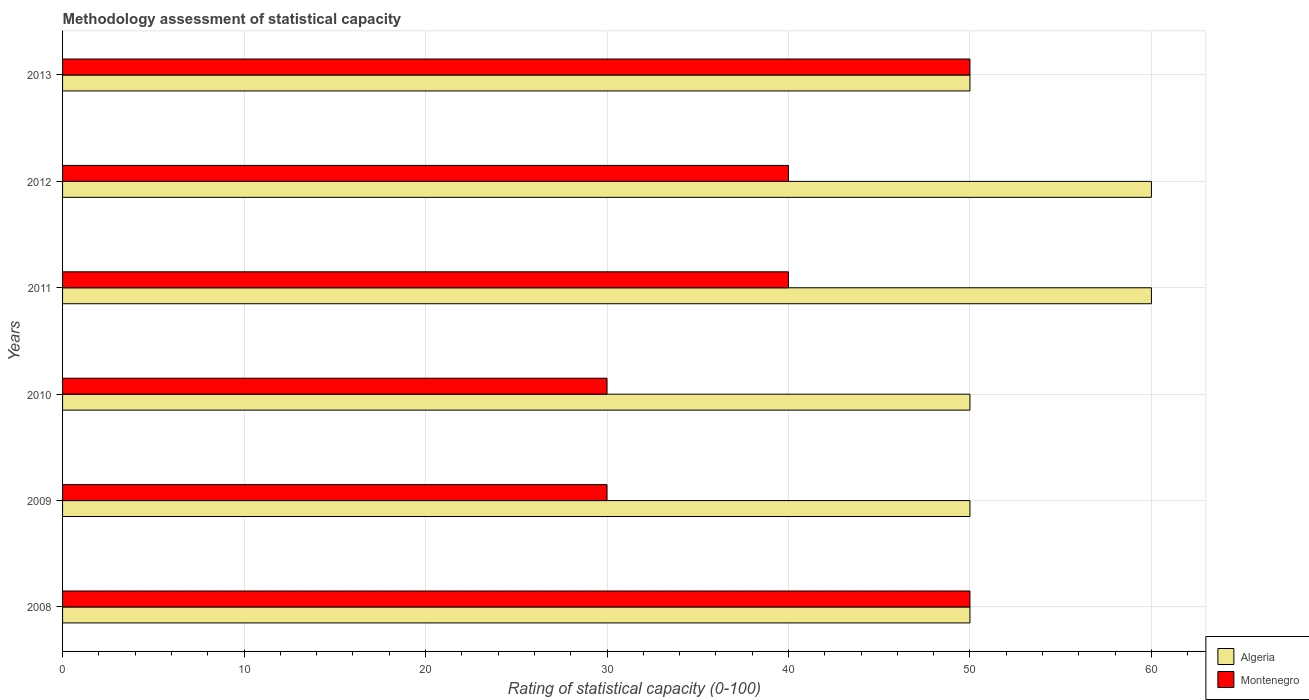How many groups of bars are there?
Offer a terse response. 6. Are the number of bars per tick equal to the number of legend labels?
Your response must be concise. Yes. How many bars are there on the 4th tick from the top?
Your answer should be compact. 2. In how many cases, is the number of bars for a given year not equal to the number of legend labels?
Your answer should be compact. 0. What is the rating of statistical capacity in Montenegro in 2008?
Ensure brevity in your answer.  50. Across all years, what is the maximum rating of statistical capacity in Montenegro?
Provide a short and direct response. 50. Across all years, what is the minimum rating of statistical capacity in Algeria?
Your answer should be very brief. 50. What is the total rating of statistical capacity in Algeria in the graph?
Offer a terse response. 320. What is the difference between the rating of statistical capacity in Montenegro in 2008 and that in 2012?
Ensure brevity in your answer.  10. What is the difference between the rating of statistical capacity in Montenegro in 2010 and the rating of statistical capacity in Algeria in 2012?
Keep it short and to the point. -30. What is the average rating of statistical capacity in Algeria per year?
Your response must be concise. 53.33. In the year 2012, what is the difference between the rating of statistical capacity in Algeria and rating of statistical capacity in Montenegro?
Give a very brief answer. 20. What is the ratio of the rating of statistical capacity in Algeria in 2008 to that in 2011?
Give a very brief answer. 0.83. Is the difference between the rating of statistical capacity in Algeria in 2011 and 2013 greater than the difference between the rating of statistical capacity in Montenegro in 2011 and 2013?
Your response must be concise. Yes. What is the difference between the highest and the lowest rating of statistical capacity in Algeria?
Make the answer very short. 10. What does the 2nd bar from the top in 2013 represents?
Make the answer very short. Algeria. What does the 1st bar from the bottom in 2009 represents?
Provide a succinct answer. Algeria. Are all the bars in the graph horizontal?
Ensure brevity in your answer.  Yes. Does the graph contain grids?
Make the answer very short. Yes. How many legend labels are there?
Keep it short and to the point. 2. What is the title of the graph?
Provide a short and direct response. Methodology assessment of statistical capacity. Does "Brunei Darussalam" appear as one of the legend labels in the graph?
Provide a succinct answer. No. What is the label or title of the X-axis?
Make the answer very short. Rating of statistical capacity (0-100). What is the label or title of the Y-axis?
Ensure brevity in your answer.  Years. What is the Rating of statistical capacity (0-100) of Algeria in 2009?
Your answer should be compact. 50. What is the Rating of statistical capacity (0-100) of Algeria in 2010?
Keep it short and to the point. 50. What is the Rating of statistical capacity (0-100) in Montenegro in 2010?
Offer a terse response. 30. What is the Rating of statistical capacity (0-100) in Algeria in 2012?
Offer a terse response. 60. What is the Rating of statistical capacity (0-100) of Montenegro in 2012?
Your response must be concise. 40. What is the Rating of statistical capacity (0-100) of Algeria in 2013?
Your response must be concise. 50. What is the Rating of statistical capacity (0-100) of Montenegro in 2013?
Make the answer very short. 50. Across all years, what is the maximum Rating of statistical capacity (0-100) in Algeria?
Give a very brief answer. 60. Across all years, what is the minimum Rating of statistical capacity (0-100) in Algeria?
Make the answer very short. 50. What is the total Rating of statistical capacity (0-100) in Algeria in the graph?
Provide a short and direct response. 320. What is the total Rating of statistical capacity (0-100) of Montenegro in the graph?
Provide a succinct answer. 240. What is the difference between the Rating of statistical capacity (0-100) in Montenegro in 2008 and that in 2010?
Your answer should be very brief. 20. What is the difference between the Rating of statistical capacity (0-100) of Algeria in 2008 and that in 2011?
Make the answer very short. -10. What is the difference between the Rating of statistical capacity (0-100) of Montenegro in 2008 and that in 2011?
Offer a very short reply. 10. What is the difference between the Rating of statistical capacity (0-100) in Algeria in 2008 and that in 2013?
Provide a short and direct response. 0. What is the difference between the Rating of statistical capacity (0-100) of Montenegro in 2009 and that in 2010?
Your answer should be very brief. 0. What is the difference between the Rating of statistical capacity (0-100) of Montenegro in 2009 and that in 2011?
Provide a short and direct response. -10. What is the difference between the Rating of statistical capacity (0-100) of Montenegro in 2009 and that in 2012?
Your answer should be compact. -10. What is the difference between the Rating of statistical capacity (0-100) of Montenegro in 2010 and that in 2011?
Provide a succinct answer. -10. What is the difference between the Rating of statistical capacity (0-100) of Montenegro in 2010 and that in 2013?
Offer a terse response. -20. What is the difference between the Rating of statistical capacity (0-100) of Algeria in 2011 and that in 2013?
Make the answer very short. 10. What is the difference between the Rating of statistical capacity (0-100) of Montenegro in 2012 and that in 2013?
Your response must be concise. -10. What is the difference between the Rating of statistical capacity (0-100) in Algeria in 2008 and the Rating of statistical capacity (0-100) in Montenegro in 2010?
Ensure brevity in your answer.  20. What is the difference between the Rating of statistical capacity (0-100) of Algeria in 2008 and the Rating of statistical capacity (0-100) of Montenegro in 2011?
Offer a terse response. 10. What is the difference between the Rating of statistical capacity (0-100) of Algeria in 2009 and the Rating of statistical capacity (0-100) of Montenegro in 2010?
Ensure brevity in your answer.  20. What is the difference between the Rating of statistical capacity (0-100) in Algeria in 2009 and the Rating of statistical capacity (0-100) in Montenegro in 2012?
Offer a terse response. 10. What is the difference between the Rating of statistical capacity (0-100) of Algeria in 2010 and the Rating of statistical capacity (0-100) of Montenegro in 2011?
Give a very brief answer. 10. What is the difference between the Rating of statistical capacity (0-100) of Algeria in 2010 and the Rating of statistical capacity (0-100) of Montenegro in 2012?
Make the answer very short. 10. What is the difference between the Rating of statistical capacity (0-100) in Algeria in 2011 and the Rating of statistical capacity (0-100) in Montenegro in 2012?
Offer a very short reply. 20. What is the difference between the Rating of statistical capacity (0-100) of Algeria in 2012 and the Rating of statistical capacity (0-100) of Montenegro in 2013?
Your answer should be very brief. 10. What is the average Rating of statistical capacity (0-100) of Algeria per year?
Keep it short and to the point. 53.33. In the year 2010, what is the difference between the Rating of statistical capacity (0-100) of Algeria and Rating of statistical capacity (0-100) of Montenegro?
Your answer should be very brief. 20. In the year 2012, what is the difference between the Rating of statistical capacity (0-100) of Algeria and Rating of statistical capacity (0-100) of Montenegro?
Give a very brief answer. 20. What is the ratio of the Rating of statistical capacity (0-100) in Algeria in 2008 to that in 2009?
Your answer should be compact. 1. What is the ratio of the Rating of statistical capacity (0-100) in Montenegro in 2008 to that in 2009?
Ensure brevity in your answer.  1.67. What is the ratio of the Rating of statistical capacity (0-100) in Algeria in 2008 to that in 2010?
Give a very brief answer. 1. What is the ratio of the Rating of statistical capacity (0-100) in Algeria in 2008 to that in 2011?
Ensure brevity in your answer.  0.83. What is the ratio of the Rating of statistical capacity (0-100) of Montenegro in 2008 to that in 2011?
Offer a terse response. 1.25. What is the ratio of the Rating of statistical capacity (0-100) in Algeria in 2008 to that in 2012?
Your response must be concise. 0.83. What is the ratio of the Rating of statistical capacity (0-100) of Montenegro in 2009 to that in 2010?
Your answer should be compact. 1. What is the ratio of the Rating of statistical capacity (0-100) of Algeria in 2009 to that in 2011?
Make the answer very short. 0.83. What is the ratio of the Rating of statistical capacity (0-100) in Montenegro in 2009 to that in 2012?
Your answer should be very brief. 0.75. What is the ratio of the Rating of statistical capacity (0-100) in Algeria in 2010 to that in 2011?
Provide a succinct answer. 0.83. What is the ratio of the Rating of statistical capacity (0-100) in Algeria in 2010 to that in 2013?
Your response must be concise. 1. What is the ratio of the Rating of statistical capacity (0-100) of Montenegro in 2010 to that in 2013?
Offer a terse response. 0.6. What is the ratio of the Rating of statistical capacity (0-100) of Algeria in 2011 to that in 2012?
Your answer should be compact. 1. What is the ratio of the Rating of statistical capacity (0-100) in Algeria in 2011 to that in 2013?
Your answer should be compact. 1.2. What is the ratio of the Rating of statistical capacity (0-100) in Montenegro in 2012 to that in 2013?
Your response must be concise. 0.8. What is the difference between the highest and the second highest Rating of statistical capacity (0-100) in Algeria?
Your response must be concise. 0. What is the difference between the highest and the second highest Rating of statistical capacity (0-100) of Montenegro?
Your answer should be very brief. 0. What is the difference between the highest and the lowest Rating of statistical capacity (0-100) in Algeria?
Offer a terse response. 10. What is the difference between the highest and the lowest Rating of statistical capacity (0-100) in Montenegro?
Make the answer very short. 20. 